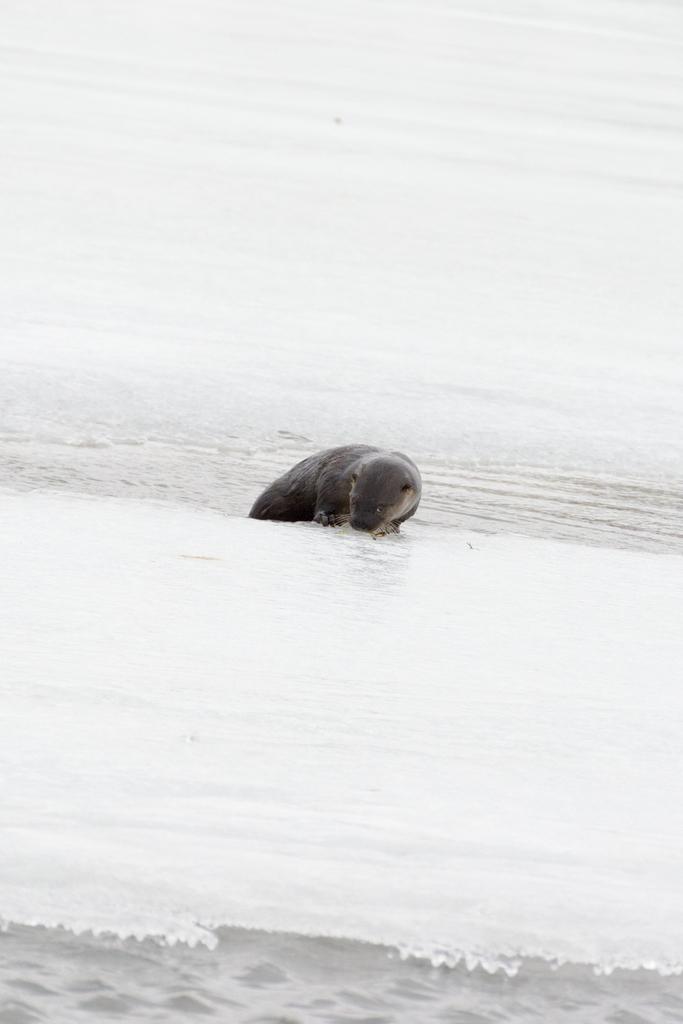Describe this image in one or two sentences. In the foreground of the picture there is ice. In the center of the picture there is a seal. At the top there is water and ice. 